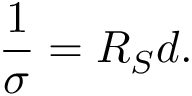<formula> <loc_0><loc_0><loc_500><loc_500>\frac { 1 } { \sigma } = R _ { S } d .</formula> 